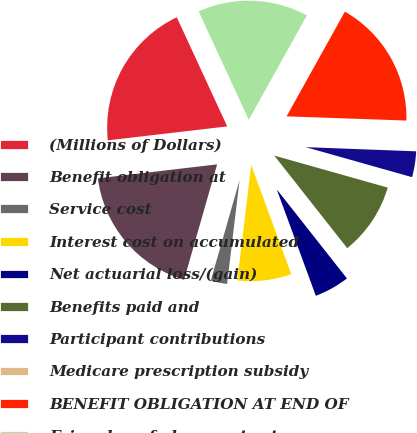Convert chart to OTSL. <chart><loc_0><loc_0><loc_500><loc_500><pie_chart><fcel>(Millions of Dollars)<fcel>Benefit obligation at<fcel>Service cost<fcel>Interest cost on accumulated<fcel>Net actuarial loss/(gain)<fcel>Benefits paid and<fcel>Participant contributions<fcel>Medicare prescription subsidy<fcel>BENEFIT OBLIGATION AT END OF<fcel>Fair value of plan assets at<nl><fcel>19.96%<fcel>18.71%<fcel>2.53%<fcel>7.51%<fcel>5.02%<fcel>10.0%<fcel>3.78%<fcel>0.04%<fcel>17.47%<fcel>14.98%<nl></chart> 